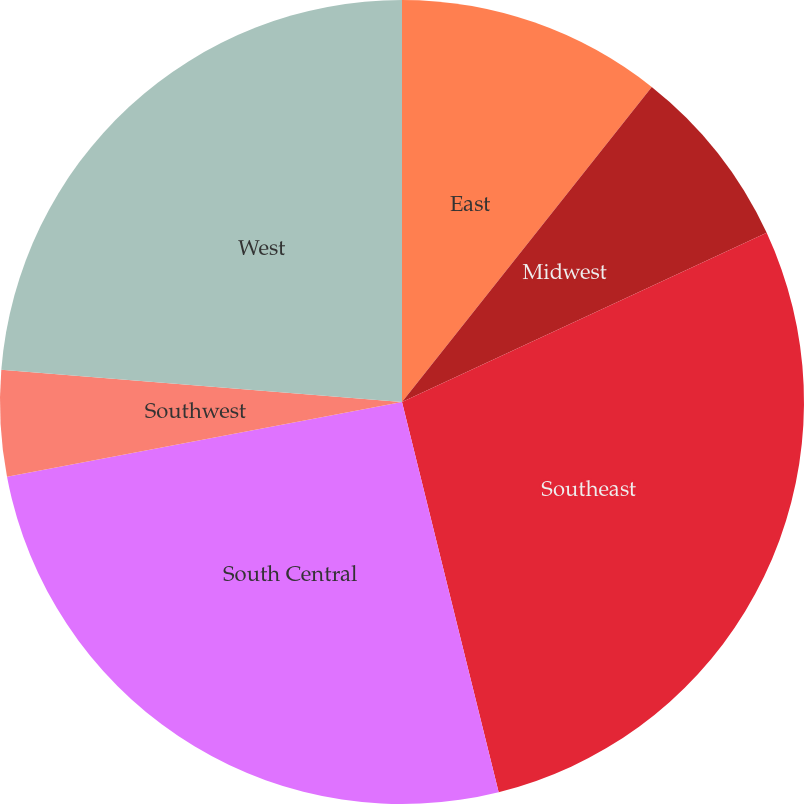<chart> <loc_0><loc_0><loc_500><loc_500><pie_chart><fcel>East<fcel>Midwest<fcel>Southeast<fcel>South Central<fcel>Southwest<fcel>West<nl><fcel>10.67%<fcel>7.42%<fcel>28.05%<fcel>25.89%<fcel>4.26%<fcel>23.72%<nl></chart> 